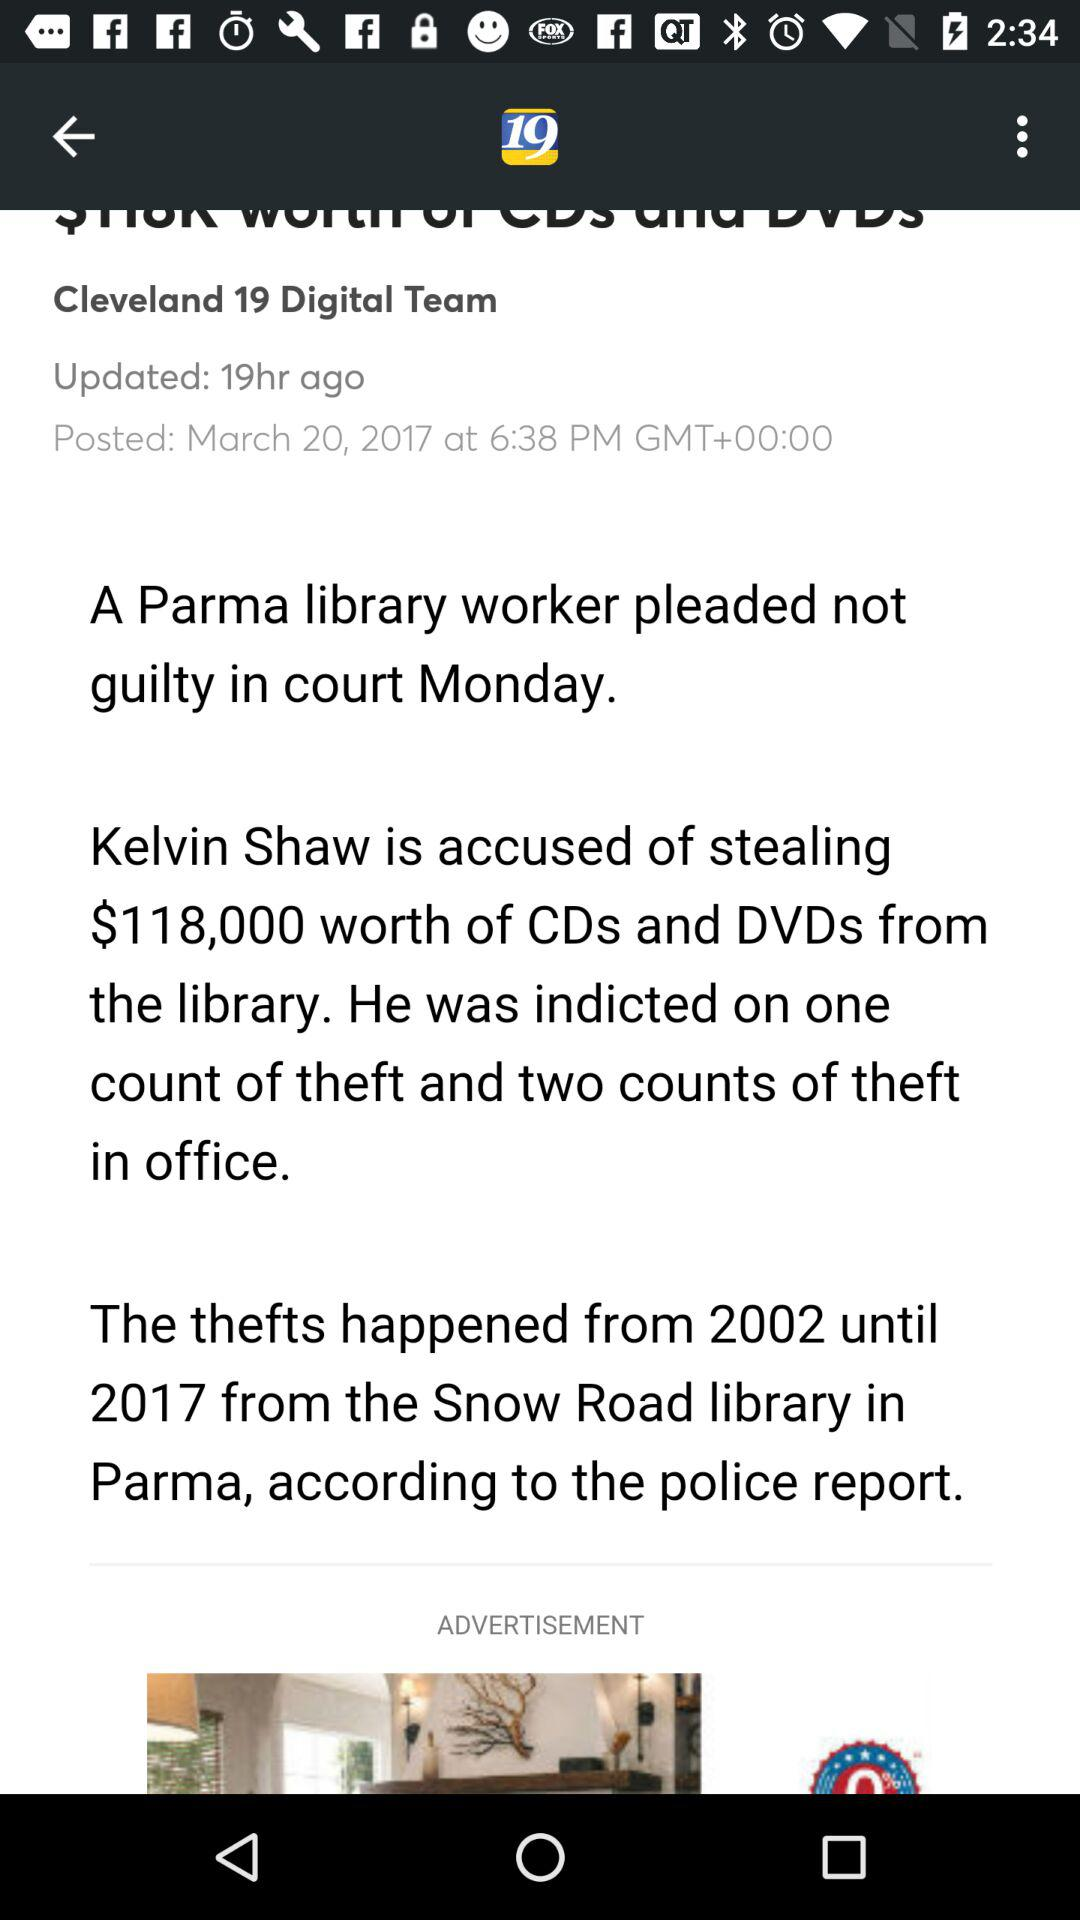What's the posted date and time of the article? The posted date is March 20, 2017 and the time is 6:38 p.m. 